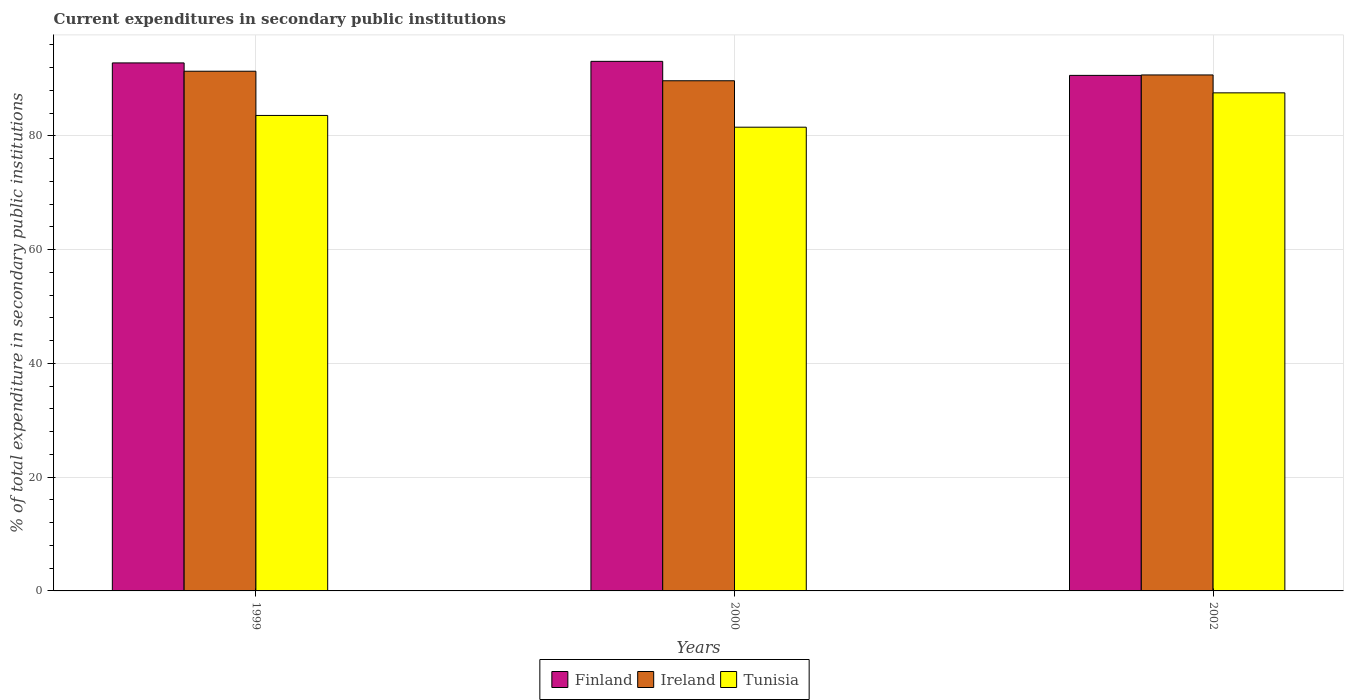How many different coloured bars are there?
Your response must be concise. 3. How many groups of bars are there?
Provide a succinct answer. 3. Are the number of bars on each tick of the X-axis equal?
Give a very brief answer. Yes. How many bars are there on the 2nd tick from the right?
Provide a succinct answer. 3. What is the label of the 2nd group of bars from the left?
Give a very brief answer. 2000. In how many cases, is the number of bars for a given year not equal to the number of legend labels?
Make the answer very short. 0. What is the current expenditures in secondary public institutions in Ireland in 1999?
Ensure brevity in your answer.  91.37. Across all years, what is the maximum current expenditures in secondary public institutions in Ireland?
Ensure brevity in your answer.  91.37. Across all years, what is the minimum current expenditures in secondary public institutions in Finland?
Provide a short and direct response. 90.64. In which year was the current expenditures in secondary public institutions in Ireland minimum?
Give a very brief answer. 2000. What is the total current expenditures in secondary public institutions in Tunisia in the graph?
Your answer should be compact. 252.71. What is the difference between the current expenditures in secondary public institutions in Finland in 1999 and that in 2000?
Provide a succinct answer. -0.27. What is the difference between the current expenditures in secondary public institutions in Tunisia in 2000 and the current expenditures in secondary public institutions in Finland in 2002?
Your answer should be very brief. -9.11. What is the average current expenditures in secondary public institutions in Finland per year?
Make the answer very short. 92.2. In the year 2000, what is the difference between the current expenditures in secondary public institutions in Tunisia and current expenditures in secondary public institutions in Ireland?
Your answer should be very brief. -8.17. In how many years, is the current expenditures in secondary public institutions in Ireland greater than 92 %?
Offer a very short reply. 0. What is the ratio of the current expenditures in secondary public institutions in Ireland in 2000 to that in 2002?
Keep it short and to the point. 0.99. Is the current expenditures in secondary public institutions in Ireland in 1999 less than that in 2000?
Make the answer very short. No. Is the difference between the current expenditures in secondary public institutions in Tunisia in 1999 and 2002 greater than the difference between the current expenditures in secondary public institutions in Ireland in 1999 and 2002?
Your answer should be compact. No. What is the difference between the highest and the second highest current expenditures in secondary public institutions in Ireland?
Your answer should be very brief. 0.65. What is the difference between the highest and the lowest current expenditures in secondary public institutions in Ireland?
Offer a very short reply. 1.68. Is the sum of the current expenditures in secondary public institutions in Ireland in 2000 and 2002 greater than the maximum current expenditures in secondary public institutions in Finland across all years?
Offer a terse response. Yes. What does the 3rd bar from the right in 1999 represents?
Provide a succinct answer. Finland. Are the values on the major ticks of Y-axis written in scientific E-notation?
Keep it short and to the point. No. Where does the legend appear in the graph?
Provide a succinct answer. Bottom center. How many legend labels are there?
Your answer should be very brief. 3. How are the legend labels stacked?
Your answer should be compact. Horizontal. What is the title of the graph?
Your answer should be compact. Current expenditures in secondary public institutions. Does "Romania" appear as one of the legend labels in the graph?
Make the answer very short. No. What is the label or title of the Y-axis?
Make the answer very short. % of total expenditure in secondary public institutions. What is the % of total expenditure in secondary public institutions of Finland in 1999?
Keep it short and to the point. 92.84. What is the % of total expenditure in secondary public institutions of Ireland in 1999?
Offer a terse response. 91.37. What is the % of total expenditure in secondary public institutions of Tunisia in 1999?
Your response must be concise. 83.6. What is the % of total expenditure in secondary public institutions of Finland in 2000?
Offer a terse response. 93.11. What is the % of total expenditure in secondary public institutions of Ireland in 2000?
Offer a very short reply. 89.7. What is the % of total expenditure in secondary public institutions of Tunisia in 2000?
Your response must be concise. 81.53. What is the % of total expenditure in secondary public institutions in Finland in 2002?
Offer a terse response. 90.64. What is the % of total expenditure in secondary public institutions of Ireland in 2002?
Ensure brevity in your answer.  90.72. What is the % of total expenditure in secondary public institutions in Tunisia in 2002?
Offer a terse response. 87.57. Across all years, what is the maximum % of total expenditure in secondary public institutions in Finland?
Your answer should be compact. 93.11. Across all years, what is the maximum % of total expenditure in secondary public institutions of Ireland?
Your answer should be compact. 91.37. Across all years, what is the maximum % of total expenditure in secondary public institutions in Tunisia?
Offer a very short reply. 87.57. Across all years, what is the minimum % of total expenditure in secondary public institutions of Finland?
Give a very brief answer. 90.64. Across all years, what is the minimum % of total expenditure in secondary public institutions of Ireland?
Offer a very short reply. 89.7. Across all years, what is the minimum % of total expenditure in secondary public institutions of Tunisia?
Provide a succinct answer. 81.53. What is the total % of total expenditure in secondary public institutions in Finland in the graph?
Your answer should be very brief. 276.59. What is the total % of total expenditure in secondary public institutions of Ireland in the graph?
Keep it short and to the point. 271.8. What is the total % of total expenditure in secondary public institutions in Tunisia in the graph?
Give a very brief answer. 252.71. What is the difference between the % of total expenditure in secondary public institutions in Finland in 1999 and that in 2000?
Make the answer very short. -0.27. What is the difference between the % of total expenditure in secondary public institutions in Ireland in 1999 and that in 2000?
Give a very brief answer. 1.68. What is the difference between the % of total expenditure in secondary public institutions of Tunisia in 1999 and that in 2000?
Keep it short and to the point. 2.07. What is the difference between the % of total expenditure in secondary public institutions of Finland in 1999 and that in 2002?
Keep it short and to the point. 2.19. What is the difference between the % of total expenditure in secondary public institutions of Ireland in 1999 and that in 2002?
Your response must be concise. 0.65. What is the difference between the % of total expenditure in secondary public institutions of Tunisia in 1999 and that in 2002?
Offer a terse response. -3.97. What is the difference between the % of total expenditure in secondary public institutions of Finland in 2000 and that in 2002?
Provide a short and direct response. 2.47. What is the difference between the % of total expenditure in secondary public institutions in Ireland in 2000 and that in 2002?
Give a very brief answer. -1.02. What is the difference between the % of total expenditure in secondary public institutions of Tunisia in 2000 and that in 2002?
Ensure brevity in your answer.  -6.04. What is the difference between the % of total expenditure in secondary public institutions in Finland in 1999 and the % of total expenditure in secondary public institutions in Ireland in 2000?
Provide a short and direct response. 3.14. What is the difference between the % of total expenditure in secondary public institutions of Finland in 1999 and the % of total expenditure in secondary public institutions of Tunisia in 2000?
Your response must be concise. 11.3. What is the difference between the % of total expenditure in secondary public institutions of Ireland in 1999 and the % of total expenditure in secondary public institutions of Tunisia in 2000?
Your answer should be very brief. 9.84. What is the difference between the % of total expenditure in secondary public institutions of Finland in 1999 and the % of total expenditure in secondary public institutions of Ireland in 2002?
Give a very brief answer. 2.11. What is the difference between the % of total expenditure in secondary public institutions in Finland in 1999 and the % of total expenditure in secondary public institutions in Tunisia in 2002?
Offer a very short reply. 5.26. What is the difference between the % of total expenditure in secondary public institutions in Ireland in 1999 and the % of total expenditure in secondary public institutions in Tunisia in 2002?
Give a very brief answer. 3.8. What is the difference between the % of total expenditure in secondary public institutions of Finland in 2000 and the % of total expenditure in secondary public institutions of Ireland in 2002?
Your answer should be compact. 2.39. What is the difference between the % of total expenditure in secondary public institutions in Finland in 2000 and the % of total expenditure in secondary public institutions in Tunisia in 2002?
Your response must be concise. 5.54. What is the difference between the % of total expenditure in secondary public institutions of Ireland in 2000 and the % of total expenditure in secondary public institutions of Tunisia in 2002?
Make the answer very short. 2.13. What is the average % of total expenditure in secondary public institutions of Finland per year?
Give a very brief answer. 92.2. What is the average % of total expenditure in secondary public institutions in Ireland per year?
Make the answer very short. 90.6. What is the average % of total expenditure in secondary public institutions in Tunisia per year?
Ensure brevity in your answer.  84.24. In the year 1999, what is the difference between the % of total expenditure in secondary public institutions of Finland and % of total expenditure in secondary public institutions of Ireland?
Provide a short and direct response. 1.46. In the year 1999, what is the difference between the % of total expenditure in secondary public institutions in Finland and % of total expenditure in secondary public institutions in Tunisia?
Provide a succinct answer. 9.24. In the year 1999, what is the difference between the % of total expenditure in secondary public institutions in Ireland and % of total expenditure in secondary public institutions in Tunisia?
Your answer should be very brief. 7.77. In the year 2000, what is the difference between the % of total expenditure in secondary public institutions of Finland and % of total expenditure in secondary public institutions of Ireland?
Ensure brevity in your answer.  3.41. In the year 2000, what is the difference between the % of total expenditure in secondary public institutions in Finland and % of total expenditure in secondary public institutions in Tunisia?
Your response must be concise. 11.58. In the year 2000, what is the difference between the % of total expenditure in secondary public institutions of Ireland and % of total expenditure in secondary public institutions of Tunisia?
Offer a terse response. 8.17. In the year 2002, what is the difference between the % of total expenditure in secondary public institutions of Finland and % of total expenditure in secondary public institutions of Ireland?
Your answer should be compact. -0.08. In the year 2002, what is the difference between the % of total expenditure in secondary public institutions in Finland and % of total expenditure in secondary public institutions in Tunisia?
Give a very brief answer. 3.07. In the year 2002, what is the difference between the % of total expenditure in secondary public institutions of Ireland and % of total expenditure in secondary public institutions of Tunisia?
Provide a succinct answer. 3.15. What is the ratio of the % of total expenditure in secondary public institutions in Finland in 1999 to that in 2000?
Ensure brevity in your answer.  1. What is the ratio of the % of total expenditure in secondary public institutions in Ireland in 1999 to that in 2000?
Your answer should be compact. 1.02. What is the ratio of the % of total expenditure in secondary public institutions of Tunisia in 1999 to that in 2000?
Offer a terse response. 1.03. What is the ratio of the % of total expenditure in secondary public institutions in Finland in 1999 to that in 2002?
Provide a short and direct response. 1.02. What is the ratio of the % of total expenditure in secondary public institutions in Ireland in 1999 to that in 2002?
Offer a very short reply. 1.01. What is the ratio of the % of total expenditure in secondary public institutions in Tunisia in 1999 to that in 2002?
Provide a succinct answer. 0.95. What is the ratio of the % of total expenditure in secondary public institutions in Finland in 2000 to that in 2002?
Give a very brief answer. 1.03. What is the ratio of the % of total expenditure in secondary public institutions of Ireland in 2000 to that in 2002?
Offer a very short reply. 0.99. What is the ratio of the % of total expenditure in secondary public institutions in Tunisia in 2000 to that in 2002?
Offer a terse response. 0.93. What is the difference between the highest and the second highest % of total expenditure in secondary public institutions in Finland?
Your answer should be compact. 0.27. What is the difference between the highest and the second highest % of total expenditure in secondary public institutions in Ireland?
Provide a short and direct response. 0.65. What is the difference between the highest and the second highest % of total expenditure in secondary public institutions in Tunisia?
Offer a terse response. 3.97. What is the difference between the highest and the lowest % of total expenditure in secondary public institutions in Finland?
Ensure brevity in your answer.  2.47. What is the difference between the highest and the lowest % of total expenditure in secondary public institutions of Ireland?
Keep it short and to the point. 1.68. What is the difference between the highest and the lowest % of total expenditure in secondary public institutions of Tunisia?
Provide a succinct answer. 6.04. 